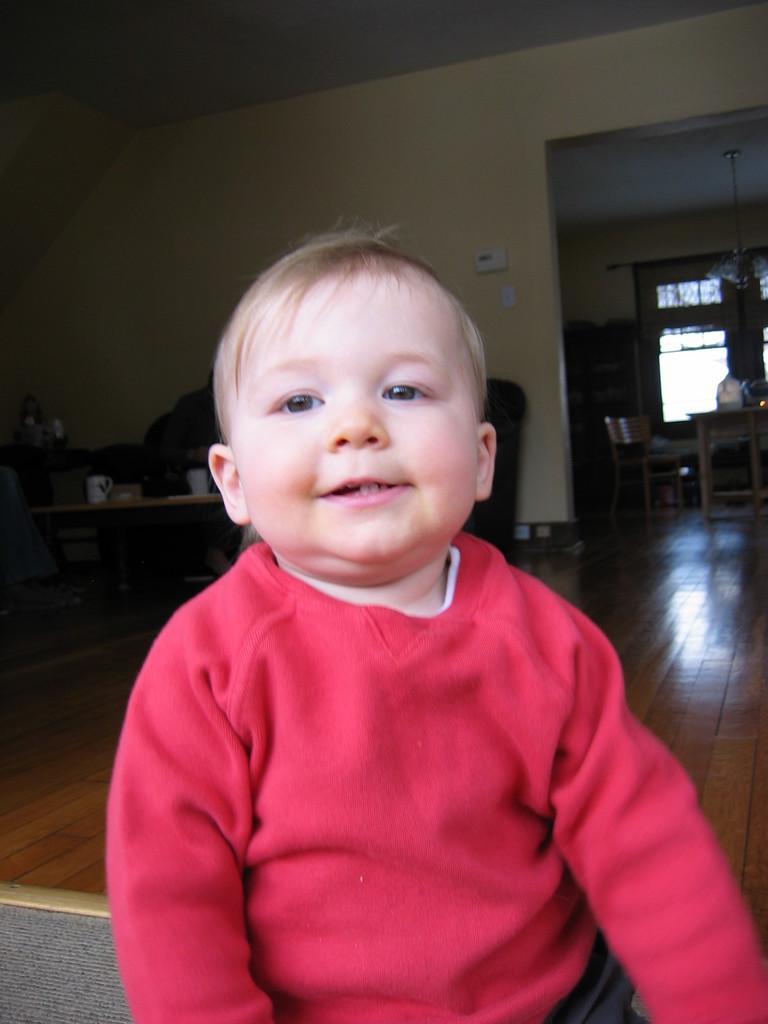What is the main subject of the image? There is a baby in the image. What is the baby wearing? The baby is wearing a red top. What can be seen on the table in the image? There is a cup and other objects on the table in the image. What type of furniture is present in the image? There are chairs and a table in the image. What is visible in the background of the image? There is a window and a wall in the image. How much tax is the baby paying in the image? There is no mention of tax in the image, as it features a baby wearing a red top and various objects and furniture. 